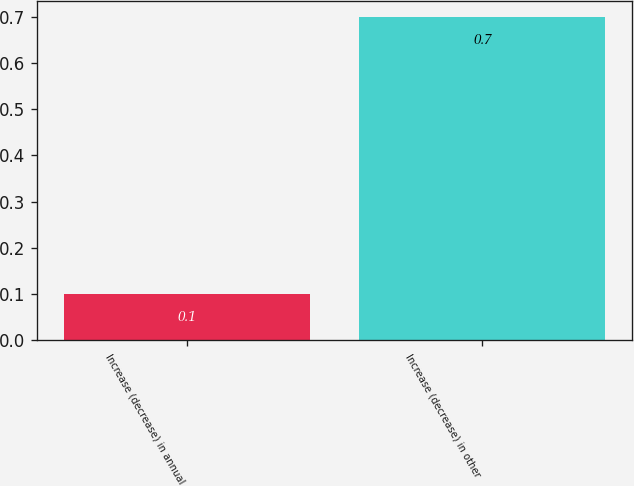Convert chart. <chart><loc_0><loc_0><loc_500><loc_500><bar_chart><fcel>Increase (decrease) in annual<fcel>Increase (decrease) in other<nl><fcel>0.1<fcel>0.7<nl></chart> 